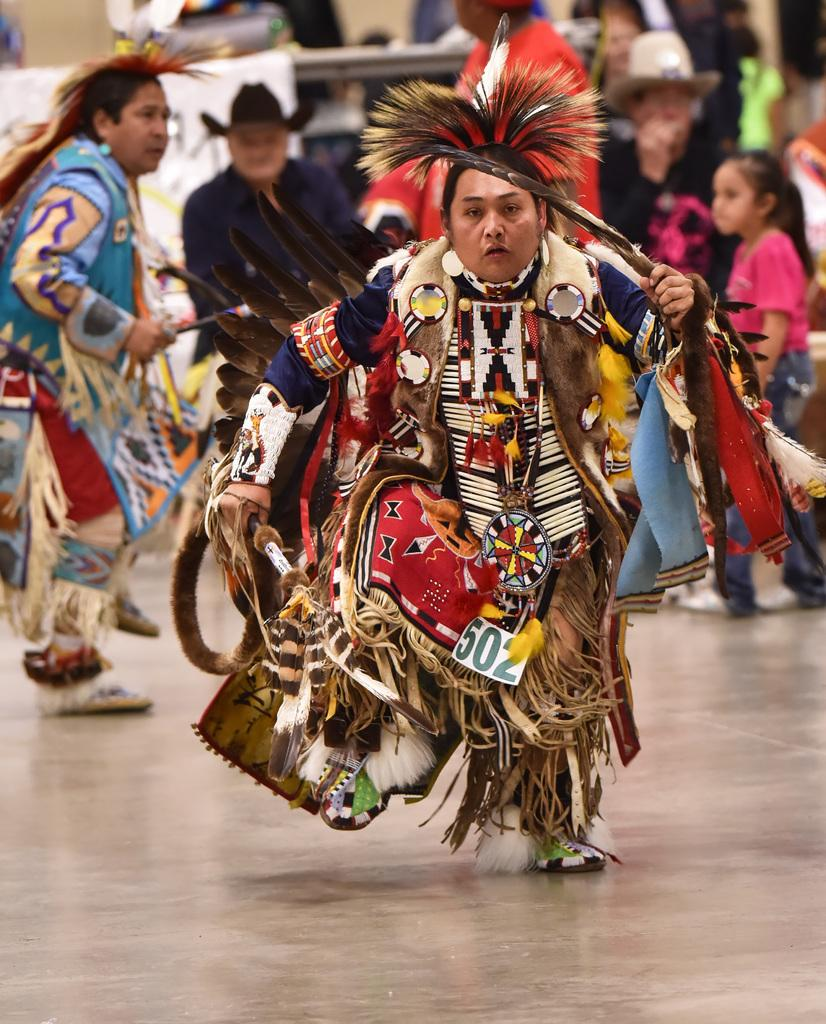What can be observed about the two people in the image? There are two people with costumes in the image. What can be seen in the background of the image? There are other people with different color dresses in the background of the image. How would you describe the background of the image? The background is blurred. What type of spade is being used by the people in the image? There is no spade present in the image. Can you see a swing in the background of the image? There is no swing visible in the image. 